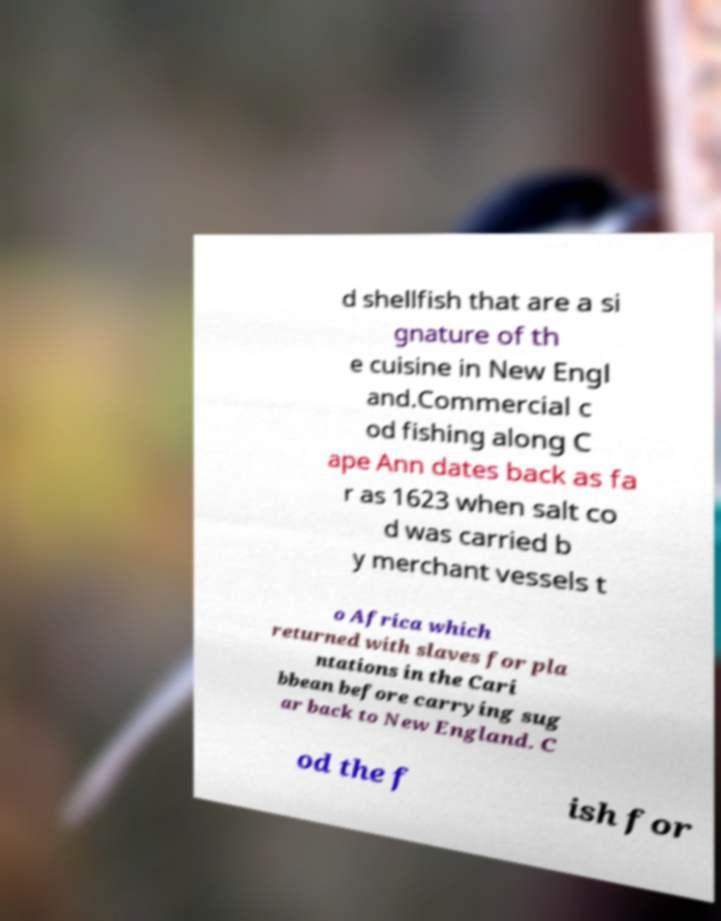Could you extract and type out the text from this image? d shellfish that are a si gnature of th e cuisine in New Engl and.Commercial c od fishing along C ape Ann dates back as fa r as 1623 when salt co d was carried b y merchant vessels t o Africa which returned with slaves for pla ntations in the Cari bbean before carrying sug ar back to New England. C od the f ish for 